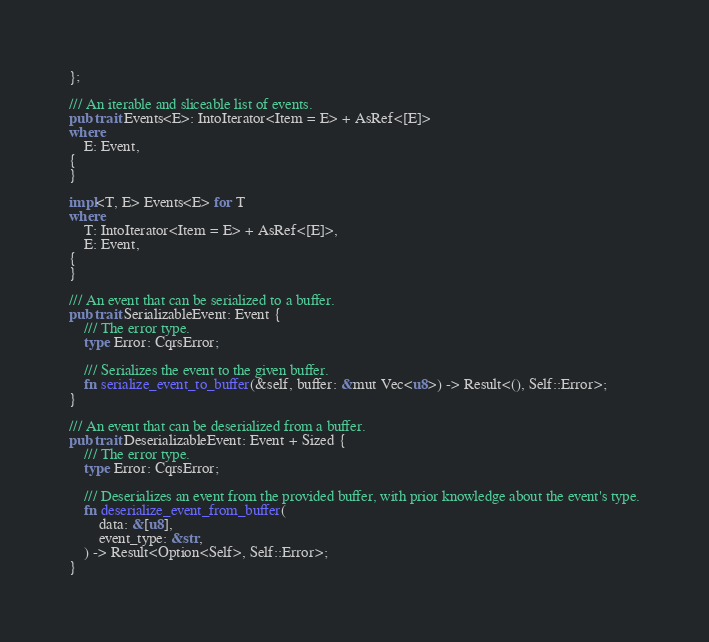Convert code to text. <code><loc_0><loc_0><loc_500><loc_500><_Rust_>};

/// An iterable and sliceable list of events.
pub trait Events<E>: IntoIterator<Item = E> + AsRef<[E]>
where
    E: Event,
{
}

impl<T, E> Events<E> for T
where
    T: IntoIterator<Item = E> + AsRef<[E]>,
    E: Event,
{
}

/// An event that can be serialized to a buffer.
pub trait SerializableEvent: Event {
    /// The error type.
    type Error: CqrsError;

    /// Serializes the event to the given buffer.
    fn serialize_event_to_buffer(&self, buffer: &mut Vec<u8>) -> Result<(), Self::Error>;
}

/// An event that can be deserialized from a buffer.
pub trait DeserializableEvent: Event + Sized {
    /// The error type.
    type Error: CqrsError;

    /// Deserializes an event from the provided buffer, with prior knowledge about the event's type.
    fn deserialize_event_from_buffer(
        data: &[u8],
        event_type: &str,
    ) -> Result<Option<Self>, Self::Error>;
}
</code> 